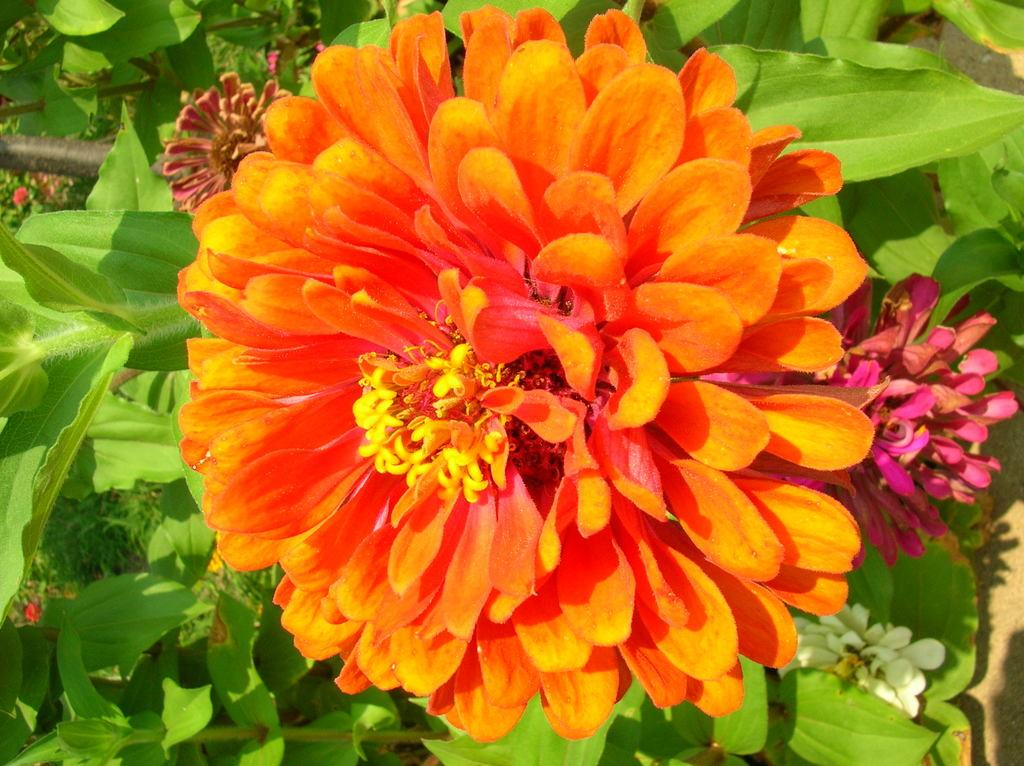What types of living organisms are present in the image? The image contains flowers and plants. Can you describe the color of the flowers or plants? The provided facts do not mention the color of the flowers or plants. What is located on the left side of the image? There is a black color object on the left side of the image. How does the sail help the wound heal in the image? There is no sail or wound present in the image; it contains flowers, plants, and a black color object. 